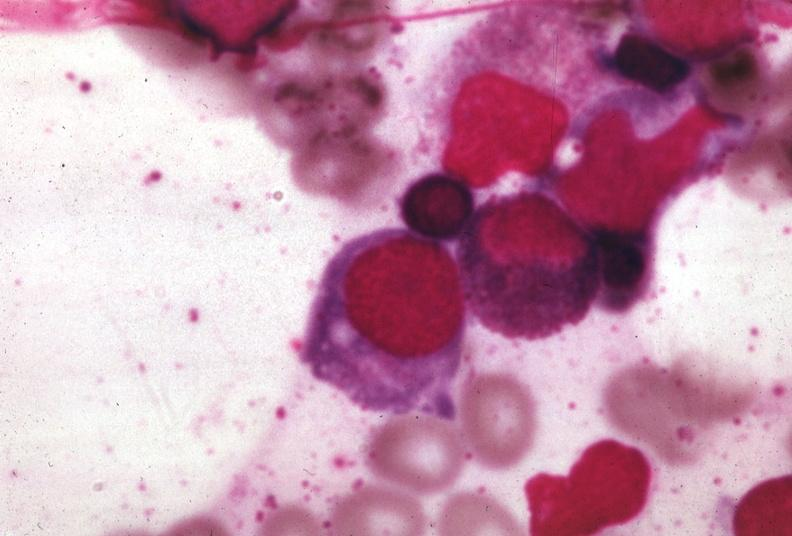what does this image show?
Answer the question using a single word or phrase. Wrights 